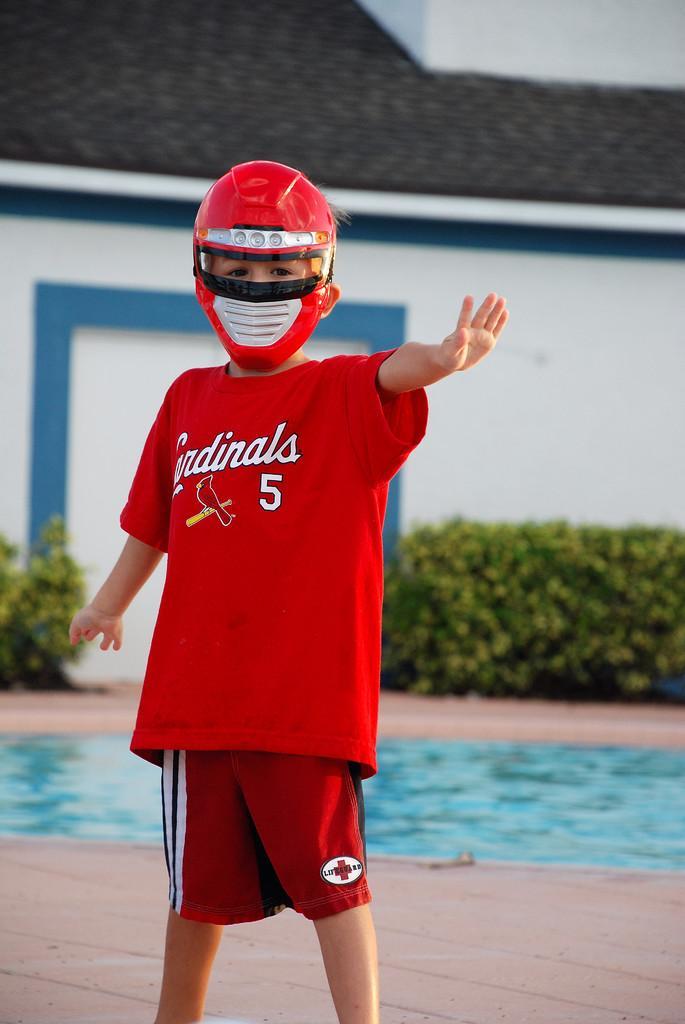Please provide a concise description of this image. In the center of the image there is a boy wearing a helmet. In the background of the image there is a house. There is a swimming pool. At the bottom of the image there is floor. 